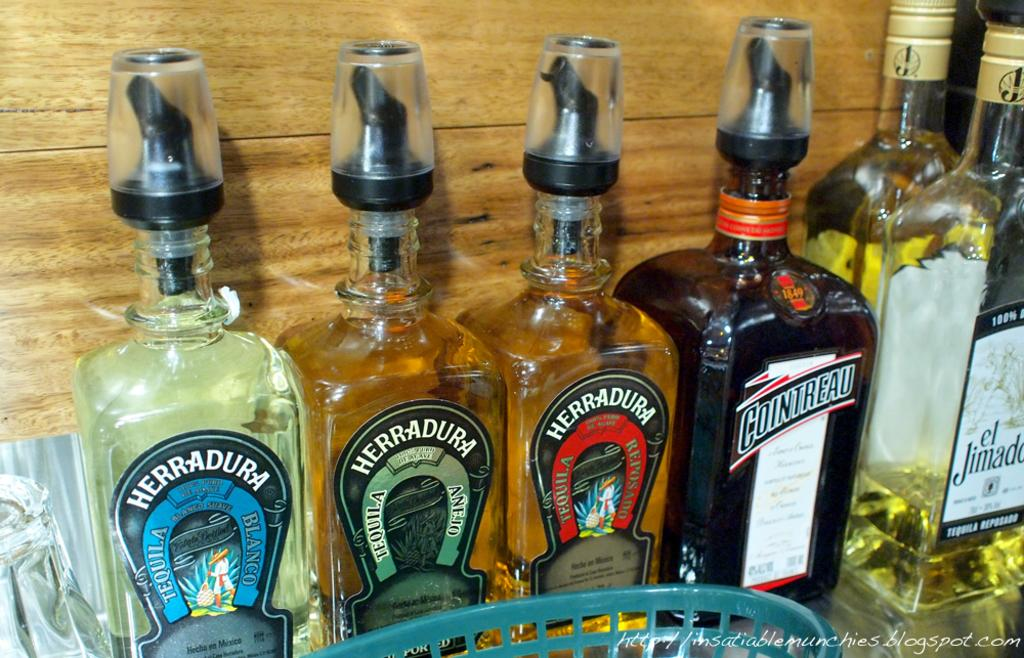Provide a one-sentence caption for the provided image. A couple of Herradura tequila bottles are displayed on a shelf. 